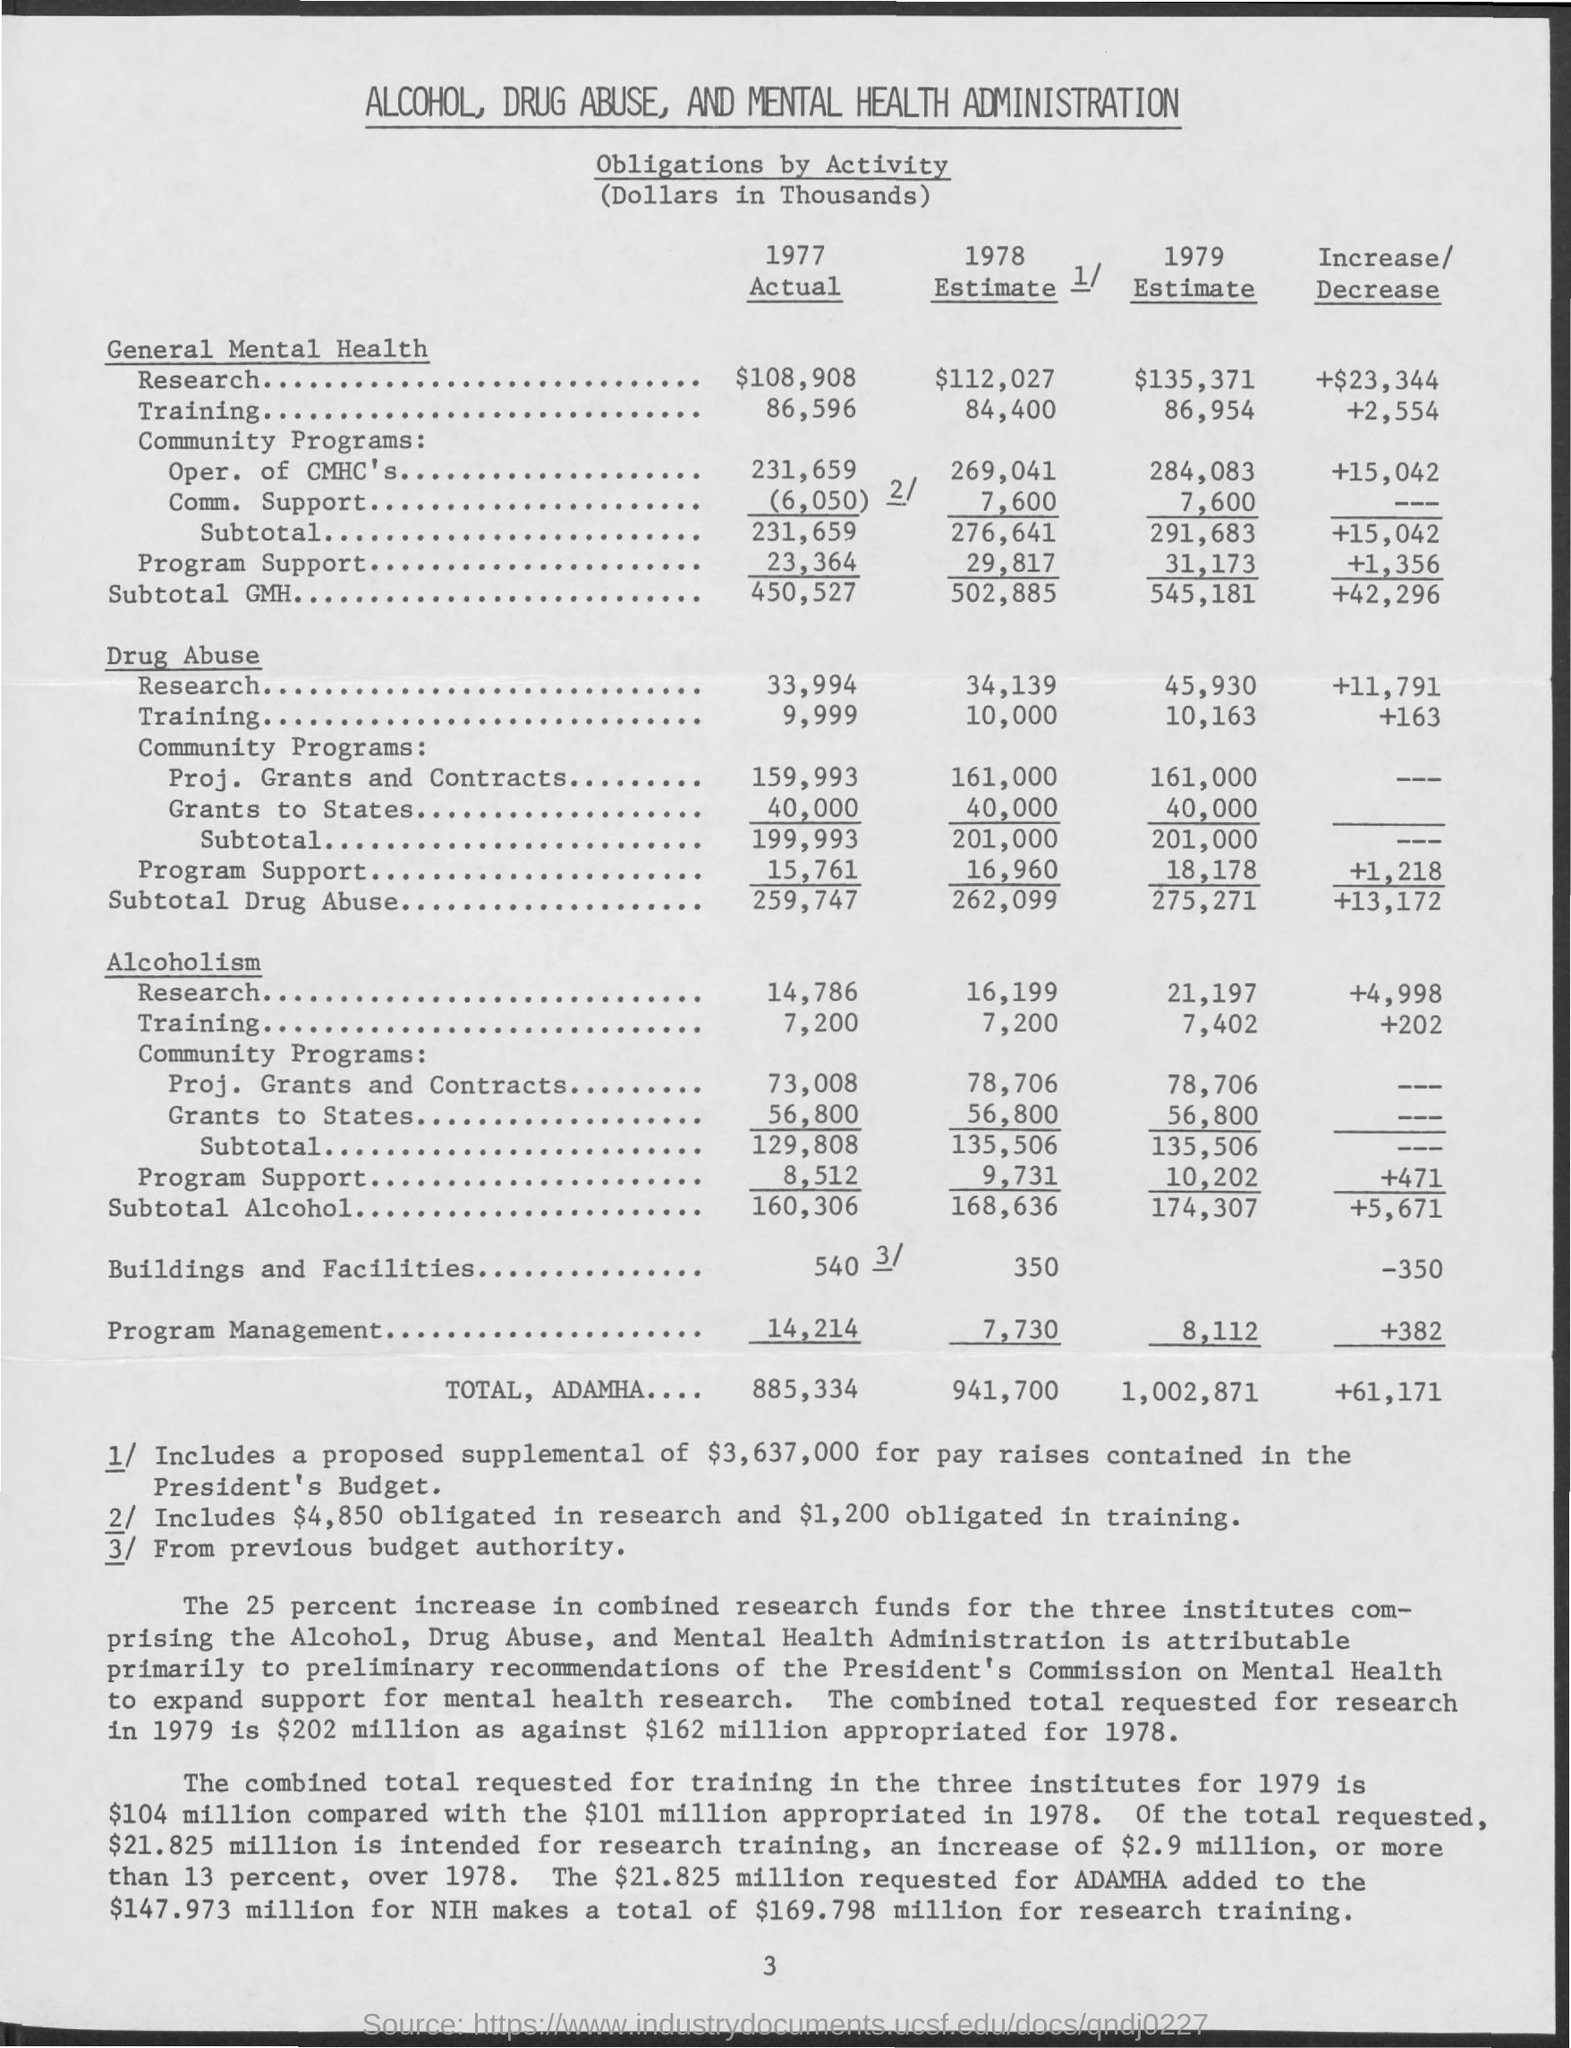Highlight a few significant elements in this photo. According to the general mental health research conducted in 1977, the total amount spent was $108,908. The total amount of increase or decrease is +61,171. The total estimate for 1979 is 1,002,871. The total amount of actual 1977 is 885,334. 